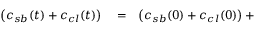<formula> <loc_0><loc_0><loc_500><loc_500>\begin{array} { r l r } { \left ( c _ { s b } ( t ) + c _ { c l } ( t ) \right ) } & = } & { \left ( c _ { s b } ( 0 ) + c _ { c l } ( 0 ) \right ) + } \end{array}</formula> 